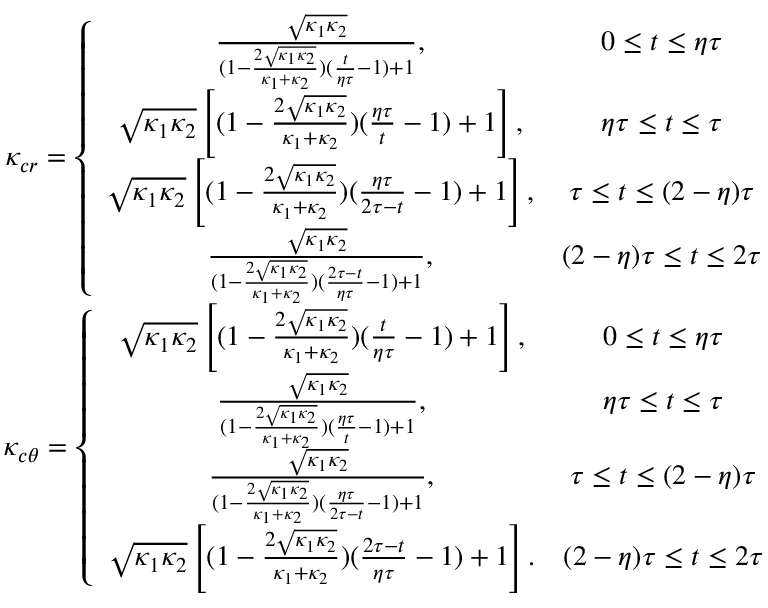Convert formula to latex. <formula><loc_0><loc_0><loc_500><loc_500>\begin{array} { c } { \kappa _ { c r } = \left \{ \begin{array} { c c } { \frac { \sqrt { \kappa _ { 1 } \kappa _ { 2 } } } { ( 1 - \frac { 2 \sqrt { \kappa _ { 1 } \kappa _ { 2 } } } { \kappa _ { 1 } + \kappa _ { 2 } } ) ( \frac { t } { \eta \tau } - 1 ) + 1 } , } & { 0 \leq t \leq \eta \tau } \\ { \sqrt { \kappa _ { 1 } \kappa _ { 2 } } \left [ ( 1 - \frac { 2 \sqrt { \kappa _ { 1 } \kappa _ { 2 } } } { \kappa _ { 1 } + \kappa _ { 2 } } ) ( \frac { \eta \tau } { t } - 1 ) + 1 \right ] , } & { \eta \tau \leq t \leq \tau } \\ { \sqrt { \kappa _ { 1 } \kappa _ { 2 } } \left [ ( 1 - \frac { 2 \sqrt { \kappa _ { 1 } \kappa _ { 2 } } } { \kappa _ { 1 } + \kappa _ { 2 } } ) ( \frac { \eta \tau } { 2 \tau - t } - 1 ) + 1 \right ] , } & { \tau \leq t \leq ( 2 - \eta ) \tau } \\ { \frac { \sqrt { \kappa _ { 1 } \kappa _ { 2 } } } { ( 1 - \frac { 2 \sqrt { \kappa _ { 1 } \kappa _ { 2 } } } { \kappa _ { 1 } + \kappa _ { 2 } } ) ( \frac { 2 \tau - t } { \eta \tau } - 1 ) + 1 } , } & { ( 2 - \eta ) \tau \leq t \leq 2 \tau } \end{array} } \\ { \kappa _ { c \theta } = \left \{ \begin{array} { c c } { \sqrt { \kappa _ { 1 } \kappa _ { 2 } } \left [ ( 1 - \frac { 2 \sqrt { \kappa _ { 1 } \kappa _ { 2 } } } { \kappa _ { 1 } + \kappa _ { 2 } } ) ( \frac { t } { \eta \tau } - 1 ) + 1 \right ] , } & { 0 \leq t \leq \eta \tau } \\ { \frac { \sqrt { \kappa _ { 1 } \kappa _ { 2 } } } { ( 1 - \frac { 2 \sqrt { \kappa _ { 1 } \kappa _ { 2 } } } { \kappa _ { 1 } + \kappa _ { 2 } } ) ( \frac { \eta \tau } { t } - 1 ) + 1 } , } & { \eta \tau \leq t \leq \tau } \\ { \frac { \sqrt { \kappa _ { 1 } \kappa _ { 2 } } } { ( 1 - \frac { 2 \sqrt { \kappa _ { 1 } \kappa _ { 2 } } } { \kappa _ { 1 } + \kappa _ { 2 } } ) ( \frac { \eta \tau } { 2 \tau - t } - 1 ) + 1 } , } & { \tau \leq t \leq ( 2 - \eta ) \tau } \\ { \sqrt { \kappa _ { 1 } \kappa _ { 2 } } \left [ ( 1 - \frac { 2 \sqrt { \kappa _ { 1 } \kappa _ { 2 } } } { \kappa _ { 1 } + \kappa _ { 2 } } ) ( \frac { 2 \tau - t } { \eta \tau } - 1 ) + 1 \right ] . } & { ( 2 - \eta ) \tau \leq t \leq 2 \tau } \end{array} } \end{array}</formula> 